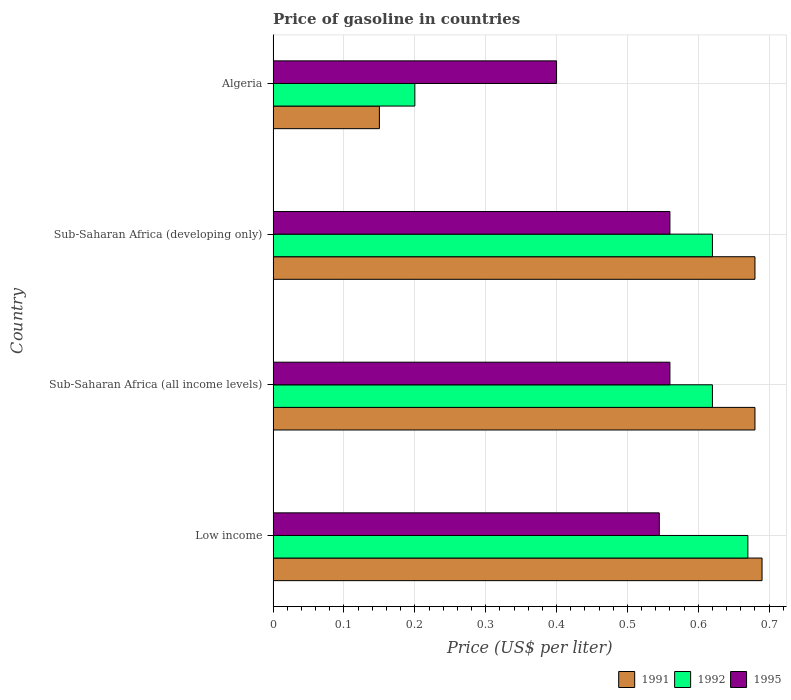How many different coloured bars are there?
Provide a succinct answer. 3. How many groups of bars are there?
Ensure brevity in your answer.  4. Are the number of bars on each tick of the Y-axis equal?
Give a very brief answer. Yes. What is the label of the 2nd group of bars from the top?
Give a very brief answer. Sub-Saharan Africa (developing only). In how many cases, is the number of bars for a given country not equal to the number of legend labels?
Your response must be concise. 0. What is the price of gasoline in 1995 in Sub-Saharan Africa (developing only)?
Keep it short and to the point. 0.56. Across all countries, what is the maximum price of gasoline in 1991?
Provide a short and direct response. 0.69. Across all countries, what is the minimum price of gasoline in 1992?
Offer a terse response. 0.2. In which country was the price of gasoline in 1992 maximum?
Ensure brevity in your answer.  Low income. In which country was the price of gasoline in 1992 minimum?
Offer a very short reply. Algeria. What is the total price of gasoline in 1995 in the graph?
Your answer should be very brief. 2.06. What is the difference between the price of gasoline in 1991 in Low income and that in Sub-Saharan Africa (developing only)?
Offer a terse response. 0.01. What is the difference between the price of gasoline in 1991 in Algeria and the price of gasoline in 1995 in Sub-Saharan Africa (developing only)?
Keep it short and to the point. -0.41. What is the average price of gasoline in 1991 per country?
Keep it short and to the point. 0.55. What is the difference between the price of gasoline in 1995 and price of gasoline in 1992 in Sub-Saharan Africa (all income levels)?
Ensure brevity in your answer.  -0.06. In how many countries, is the price of gasoline in 1992 greater than 0.14 US$?
Your answer should be compact. 4. What is the ratio of the price of gasoline in 1991 in Algeria to that in Sub-Saharan Africa (developing only)?
Your response must be concise. 0.22. Is the price of gasoline in 1992 in Algeria less than that in Low income?
Give a very brief answer. Yes. What is the difference between the highest and the second highest price of gasoline in 1992?
Offer a terse response. 0.05. What is the difference between the highest and the lowest price of gasoline in 1991?
Keep it short and to the point. 0.54. Is the sum of the price of gasoline in 1995 in Low income and Sub-Saharan Africa (developing only) greater than the maximum price of gasoline in 1991 across all countries?
Your answer should be very brief. Yes. How many bars are there?
Your answer should be compact. 12. What is the difference between two consecutive major ticks on the X-axis?
Your response must be concise. 0.1. Are the values on the major ticks of X-axis written in scientific E-notation?
Provide a succinct answer. No. How many legend labels are there?
Provide a succinct answer. 3. How are the legend labels stacked?
Make the answer very short. Horizontal. What is the title of the graph?
Give a very brief answer. Price of gasoline in countries. What is the label or title of the X-axis?
Your answer should be compact. Price (US$ per liter). What is the label or title of the Y-axis?
Your answer should be very brief. Country. What is the Price (US$ per liter) in 1991 in Low income?
Give a very brief answer. 0.69. What is the Price (US$ per liter) in 1992 in Low income?
Provide a succinct answer. 0.67. What is the Price (US$ per liter) in 1995 in Low income?
Keep it short and to the point. 0.55. What is the Price (US$ per liter) in 1991 in Sub-Saharan Africa (all income levels)?
Keep it short and to the point. 0.68. What is the Price (US$ per liter) in 1992 in Sub-Saharan Africa (all income levels)?
Your answer should be very brief. 0.62. What is the Price (US$ per liter) in 1995 in Sub-Saharan Africa (all income levels)?
Give a very brief answer. 0.56. What is the Price (US$ per liter) in 1991 in Sub-Saharan Africa (developing only)?
Keep it short and to the point. 0.68. What is the Price (US$ per liter) of 1992 in Sub-Saharan Africa (developing only)?
Your response must be concise. 0.62. What is the Price (US$ per liter) in 1995 in Sub-Saharan Africa (developing only)?
Offer a very short reply. 0.56. What is the Price (US$ per liter) in 1991 in Algeria?
Your answer should be very brief. 0.15. What is the Price (US$ per liter) in 1995 in Algeria?
Offer a terse response. 0.4. Across all countries, what is the maximum Price (US$ per liter) of 1991?
Offer a very short reply. 0.69. Across all countries, what is the maximum Price (US$ per liter) in 1992?
Your response must be concise. 0.67. Across all countries, what is the maximum Price (US$ per liter) in 1995?
Offer a very short reply. 0.56. Across all countries, what is the minimum Price (US$ per liter) in 1992?
Provide a short and direct response. 0.2. What is the total Price (US$ per liter) of 1992 in the graph?
Your response must be concise. 2.11. What is the total Price (US$ per liter) in 1995 in the graph?
Make the answer very short. 2.06. What is the difference between the Price (US$ per liter) in 1991 in Low income and that in Sub-Saharan Africa (all income levels)?
Your answer should be compact. 0.01. What is the difference between the Price (US$ per liter) in 1992 in Low income and that in Sub-Saharan Africa (all income levels)?
Your response must be concise. 0.05. What is the difference between the Price (US$ per liter) of 1995 in Low income and that in Sub-Saharan Africa (all income levels)?
Ensure brevity in your answer.  -0.01. What is the difference between the Price (US$ per liter) in 1991 in Low income and that in Sub-Saharan Africa (developing only)?
Provide a succinct answer. 0.01. What is the difference between the Price (US$ per liter) in 1995 in Low income and that in Sub-Saharan Africa (developing only)?
Make the answer very short. -0.01. What is the difference between the Price (US$ per liter) in 1991 in Low income and that in Algeria?
Ensure brevity in your answer.  0.54. What is the difference between the Price (US$ per liter) of 1992 in Low income and that in Algeria?
Provide a short and direct response. 0.47. What is the difference between the Price (US$ per liter) of 1995 in Low income and that in Algeria?
Give a very brief answer. 0.14. What is the difference between the Price (US$ per liter) in 1991 in Sub-Saharan Africa (all income levels) and that in Sub-Saharan Africa (developing only)?
Keep it short and to the point. 0. What is the difference between the Price (US$ per liter) of 1991 in Sub-Saharan Africa (all income levels) and that in Algeria?
Offer a very short reply. 0.53. What is the difference between the Price (US$ per liter) of 1992 in Sub-Saharan Africa (all income levels) and that in Algeria?
Provide a short and direct response. 0.42. What is the difference between the Price (US$ per liter) in 1995 in Sub-Saharan Africa (all income levels) and that in Algeria?
Offer a very short reply. 0.16. What is the difference between the Price (US$ per liter) of 1991 in Sub-Saharan Africa (developing only) and that in Algeria?
Make the answer very short. 0.53. What is the difference between the Price (US$ per liter) of 1992 in Sub-Saharan Africa (developing only) and that in Algeria?
Give a very brief answer. 0.42. What is the difference between the Price (US$ per liter) in 1995 in Sub-Saharan Africa (developing only) and that in Algeria?
Your response must be concise. 0.16. What is the difference between the Price (US$ per liter) of 1991 in Low income and the Price (US$ per liter) of 1992 in Sub-Saharan Africa (all income levels)?
Ensure brevity in your answer.  0.07. What is the difference between the Price (US$ per liter) of 1991 in Low income and the Price (US$ per liter) of 1995 in Sub-Saharan Africa (all income levels)?
Keep it short and to the point. 0.13. What is the difference between the Price (US$ per liter) in 1992 in Low income and the Price (US$ per liter) in 1995 in Sub-Saharan Africa (all income levels)?
Your answer should be very brief. 0.11. What is the difference between the Price (US$ per liter) of 1991 in Low income and the Price (US$ per liter) of 1992 in Sub-Saharan Africa (developing only)?
Ensure brevity in your answer.  0.07. What is the difference between the Price (US$ per liter) in 1991 in Low income and the Price (US$ per liter) in 1995 in Sub-Saharan Africa (developing only)?
Your answer should be very brief. 0.13. What is the difference between the Price (US$ per liter) of 1992 in Low income and the Price (US$ per liter) of 1995 in Sub-Saharan Africa (developing only)?
Make the answer very short. 0.11. What is the difference between the Price (US$ per liter) in 1991 in Low income and the Price (US$ per liter) in 1992 in Algeria?
Your response must be concise. 0.49. What is the difference between the Price (US$ per liter) in 1991 in Low income and the Price (US$ per liter) in 1995 in Algeria?
Provide a succinct answer. 0.29. What is the difference between the Price (US$ per liter) in 1992 in Low income and the Price (US$ per liter) in 1995 in Algeria?
Offer a terse response. 0.27. What is the difference between the Price (US$ per liter) in 1991 in Sub-Saharan Africa (all income levels) and the Price (US$ per liter) in 1995 in Sub-Saharan Africa (developing only)?
Provide a succinct answer. 0.12. What is the difference between the Price (US$ per liter) of 1991 in Sub-Saharan Africa (all income levels) and the Price (US$ per liter) of 1992 in Algeria?
Keep it short and to the point. 0.48. What is the difference between the Price (US$ per liter) of 1991 in Sub-Saharan Africa (all income levels) and the Price (US$ per liter) of 1995 in Algeria?
Keep it short and to the point. 0.28. What is the difference between the Price (US$ per liter) in 1992 in Sub-Saharan Africa (all income levels) and the Price (US$ per liter) in 1995 in Algeria?
Offer a very short reply. 0.22. What is the difference between the Price (US$ per liter) of 1991 in Sub-Saharan Africa (developing only) and the Price (US$ per liter) of 1992 in Algeria?
Your answer should be very brief. 0.48. What is the difference between the Price (US$ per liter) of 1991 in Sub-Saharan Africa (developing only) and the Price (US$ per liter) of 1995 in Algeria?
Your response must be concise. 0.28. What is the difference between the Price (US$ per liter) of 1992 in Sub-Saharan Africa (developing only) and the Price (US$ per liter) of 1995 in Algeria?
Ensure brevity in your answer.  0.22. What is the average Price (US$ per liter) of 1991 per country?
Make the answer very short. 0.55. What is the average Price (US$ per liter) in 1992 per country?
Provide a succinct answer. 0.53. What is the average Price (US$ per liter) in 1995 per country?
Provide a short and direct response. 0.52. What is the difference between the Price (US$ per liter) in 1991 and Price (US$ per liter) in 1992 in Low income?
Provide a succinct answer. 0.02. What is the difference between the Price (US$ per liter) in 1991 and Price (US$ per liter) in 1995 in Low income?
Keep it short and to the point. 0.14. What is the difference between the Price (US$ per liter) of 1991 and Price (US$ per liter) of 1995 in Sub-Saharan Africa (all income levels)?
Ensure brevity in your answer.  0.12. What is the difference between the Price (US$ per liter) of 1992 and Price (US$ per liter) of 1995 in Sub-Saharan Africa (all income levels)?
Your answer should be very brief. 0.06. What is the difference between the Price (US$ per liter) of 1991 and Price (US$ per liter) of 1992 in Sub-Saharan Africa (developing only)?
Your answer should be very brief. 0.06. What is the difference between the Price (US$ per liter) in 1991 and Price (US$ per liter) in 1995 in Sub-Saharan Africa (developing only)?
Offer a very short reply. 0.12. What is the ratio of the Price (US$ per liter) in 1991 in Low income to that in Sub-Saharan Africa (all income levels)?
Give a very brief answer. 1.01. What is the ratio of the Price (US$ per liter) of 1992 in Low income to that in Sub-Saharan Africa (all income levels)?
Your answer should be compact. 1.08. What is the ratio of the Price (US$ per liter) in 1995 in Low income to that in Sub-Saharan Africa (all income levels)?
Ensure brevity in your answer.  0.97. What is the ratio of the Price (US$ per liter) in 1991 in Low income to that in Sub-Saharan Africa (developing only)?
Keep it short and to the point. 1.01. What is the ratio of the Price (US$ per liter) in 1992 in Low income to that in Sub-Saharan Africa (developing only)?
Keep it short and to the point. 1.08. What is the ratio of the Price (US$ per liter) in 1995 in Low income to that in Sub-Saharan Africa (developing only)?
Offer a terse response. 0.97. What is the ratio of the Price (US$ per liter) of 1992 in Low income to that in Algeria?
Provide a succinct answer. 3.35. What is the ratio of the Price (US$ per liter) in 1995 in Low income to that in Algeria?
Give a very brief answer. 1.36. What is the ratio of the Price (US$ per liter) of 1991 in Sub-Saharan Africa (all income levels) to that in Sub-Saharan Africa (developing only)?
Offer a terse response. 1. What is the ratio of the Price (US$ per liter) of 1992 in Sub-Saharan Africa (all income levels) to that in Sub-Saharan Africa (developing only)?
Provide a succinct answer. 1. What is the ratio of the Price (US$ per liter) of 1995 in Sub-Saharan Africa (all income levels) to that in Sub-Saharan Africa (developing only)?
Offer a very short reply. 1. What is the ratio of the Price (US$ per liter) of 1991 in Sub-Saharan Africa (all income levels) to that in Algeria?
Offer a terse response. 4.53. What is the ratio of the Price (US$ per liter) of 1992 in Sub-Saharan Africa (all income levels) to that in Algeria?
Offer a very short reply. 3.1. What is the ratio of the Price (US$ per liter) in 1995 in Sub-Saharan Africa (all income levels) to that in Algeria?
Give a very brief answer. 1.4. What is the ratio of the Price (US$ per liter) in 1991 in Sub-Saharan Africa (developing only) to that in Algeria?
Ensure brevity in your answer.  4.53. What is the ratio of the Price (US$ per liter) of 1995 in Sub-Saharan Africa (developing only) to that in Algeria?
Provide a short and direct response. 1.4. What is the difference between the highest and the lowest Price (US$ per liter) of 1991?
Provide a short and direct response. 0.54. What is the difference between the highest and the lowest Price (US$ per liter) of 1992?
Your response must be concise. 0.47. What is the difference between the highest and the lowest Price (US$ per liter) in 1995?
Keep it short and to the point. 0.16. 